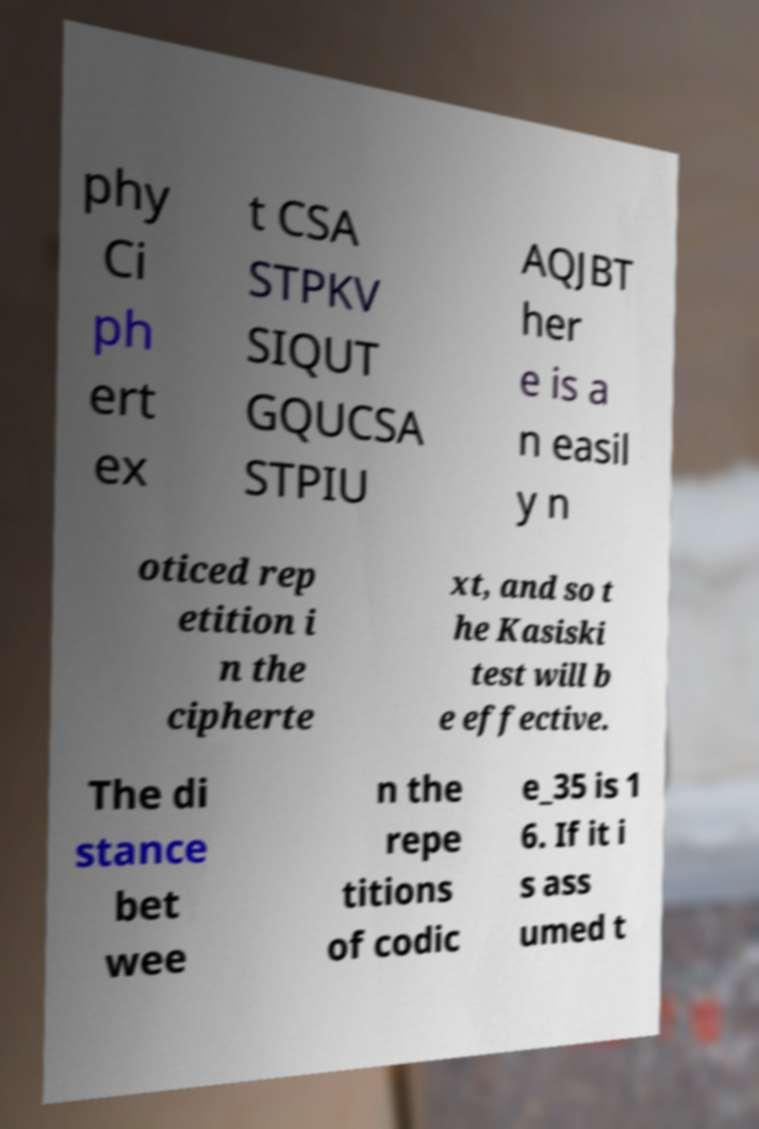Can you accurately transcribe the text from the provided image for me? phy Ci ph ert ex t CSA STPKV SIQUT GQUCSA STPIU AQJBT her e is a n easil y n oticed rep etition i n the cipherte xt, and so t he Kasiski test will b e effective. The di stance bet wee n the repe titions of codic e_35 is 1 6. If it i s ass umed t 